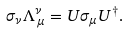Convert formula to latex. <formula><loc_0><loc_0><loc_500><loc_500>\sigma _ { \nu } \Lambda ^ { \nu } _ { \, \mu } = U \sigma _ { \mu } U ^ { \dagger } .</formula> 